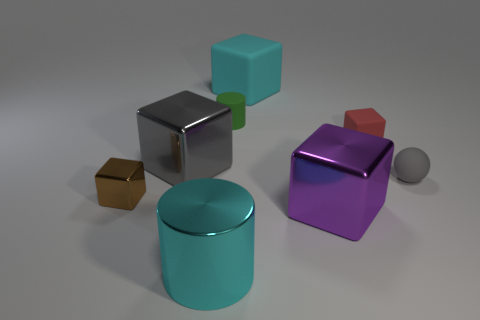How many purple things are small cylinders or big matte things?
Provide a short and direct response. 0. How many things are either blocks or things that are right of the large cylinder?
Your answer should be very brief. 7. What material is the cyan thing in front of the brown shiny object?
Keep it short and to the point. Metal. There is a cyan shiny object that is the same size as the gray metallic block; what shape is it?
Provide a succinct answer. Cylinder. Are there any large objects of the same shape as the tiny red thing?
Offer a terse response. Yes. Is the material of the large gray cube the same as the gray thing right of the small red cube?
Provide a succinct answer. No. What is the material of the large cyan thing behind the large cyan thing that is in front of the large gray metallic thing?
Provide a succinct answer. Rubber. Is the number of red things to the left of the tiny gray matte ball greater than the number of brown objects?
Provide a short and direct response. No. Is there a cyan block?
Ensure brevity in your answer.  Yes. What is the color of the big cube in front of the brown metallic block?
Ensure brevity in your answer.  Purple. 